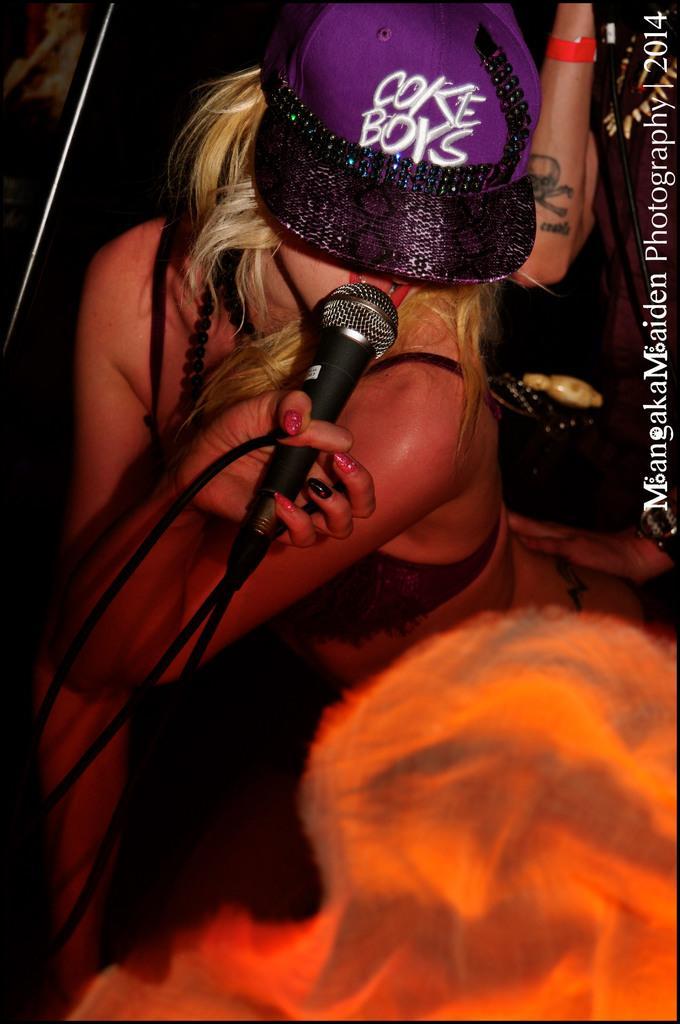Please provide a concise description of this image. In this picture there is a woman sitting and holding a mic in her hand. She is singing. There is a person and a bag in the background. 